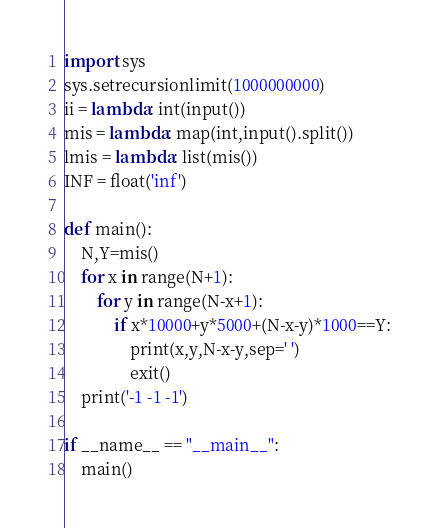<code> <loc_0><loc_0><loc_500><loc_500><_Python_>import sys
sys.setrecursionlimit(1000000000)
ii = lambda: int(input())
mis = lambda: map(int,input().split())
lmis = lambda: list(mis())
INF = float('inf')

def main():
    N,Y=mis()
    for x in range(N+1):
        for y in range(N-x+1):
            if x*10000+y*5000+(N-x-y)*1000==Y:
                print(x,y,N-x-y,sep=' ')
                exit()
    print('-1 -1 -1')

if __name__ == "__main__":
    main()</code> 